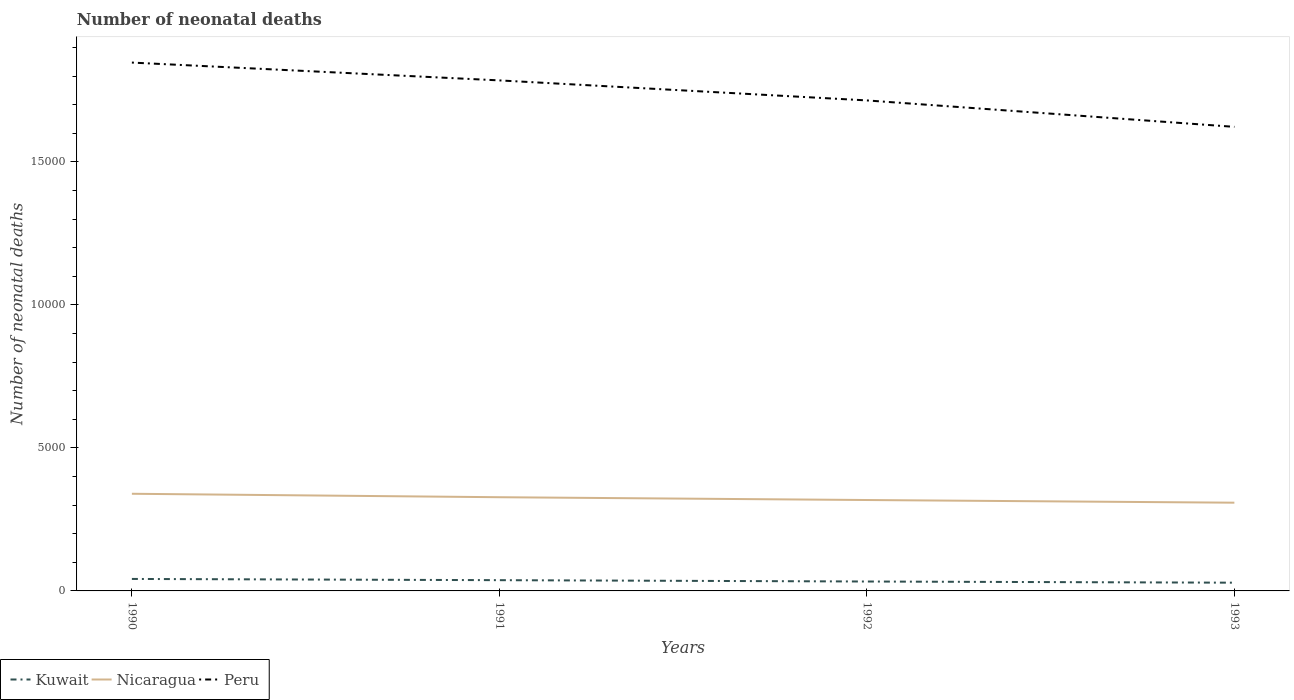Does the line corresponding to Peru intersect with the line corresponding to Nicaragua?
Your response must be concise. No. Across all years, what is the maximum number of neonatal deaths in in Kuwait?
Your answer should be very brief. 288. What is the total number of neonatal deaths in in Peru in the graph?
Provide a succinct answer. 1323. What is the difference between the highest and the second highest number of neonatal deaths in in Peru?
Offer a terse response. 2247. Is the number of neonatal deaths in in Kuwait strictly greater than the number of neonatal deaths in in Peru over the years?
Offer a very short reply. Yes. Are the values on the major ticks of Y-axis written in scientific E-notation?
Provide a short and direct response. No. Does the graph contain any zero values?
Your response must be concise. No. Where does the legend appear in the graph?
Provide a short and direct response. Bottom left. How many legend labels are there?
Keep it short and to the point. 3. How are the legend labels stacked?
Provide a succinct answer. Horizontal. What is the title of the graph?
Offer a very short reply. Number of neonatal deaths. Does "Indonesia" appear as one of the legend labels in the graph?
Provide a short and direct response. No. What is the label or title of the Y-axis?
Make the answer very short. Number of neonatal deaths. What is the Number of neonatal deaths of Kuwait in 1990?
Provide a short and direct response. 419. What is the Number of neonatal deaths of Nicaragua in 1990?
Provide a succinct answer. 3397. What is the Number of neonatal deaths of Peru in 1990?
Provide a succinct answer. 1.85e+04. What is the Number of neonatal deaths of Kuwait in 1991?
Make the answer very short. 376. What is the Number of neonatal deaths of Nicaragua in 1991?
Your answer should be compact. 3276. What is the Number of neonatal deaths of Peru in 1991?
Offer a terse response. 1.78e+04. What is the Number of neonatal deaths in Kuwait in 1992?
Your answer should be compact. 329. What is the Number of neonatal deaths of Nicaragua in 1992?
Provide a succinct answer. 3178. What is the Number of neonatal deaths of Peru in 1992?
Offer a very short reply. 1.71e+04. What is the Number of neonatal deaths in Kuwait in 1993?
Provide a short and direct response. 288. What is the Number of neonatal deaths in Nicaragua in 1993?
Keep it short and to the point. 3085. What is the Number of neonatal deaths of Peru in 1993?
Offer a terse response. 1.62e+04. Across all years, what is the maximum Number of neonatal deaths in Kuwait?
Make the answer very short. 419. Across all years, what is the maximum Number of neonatal deaths of Nicaragua?
Ensure brevity in your answer.  3397. Across all years, what is the maximum Number of neonatal deaths in Peru?
Your answer should be very brief. 1.85e+04. Across all years, what is the minimum Number of neonatal deaths of Kuwait?
Your answer should be compact. 288. Across all years, what is the minimum Number of neonatal deaths in Nicaragua?
Provide a short and direct response. 3085. Across all years, what is the minimum Number of neonatal deaths in Peru?
Keep it short and to the point. 1.62e+04. What is the total Number of neonatal deaths of Kuwait in the graph?
Offer a terse response. 1412. What is the total Number of neonatal deaths in Nicaragua in the graph?
Provide a succinct answer. 1.29e+04. What is the total Number of neonatal deaths of Peru in the graph?
Your answer should be very brief. 6.97e+04. What is the difference between the Number of neonatal deaths of Kuwait in 1990 and that in 1991?
Offer a very short reply. 43. What is the difference between the Number of neonatal deaths of Nicaragua in 1990 and that in 1991?
Your answer should be compact. 121. What is the difference between the Number of neonatal deaths in Peru in 1990 and that in 1991?
Provide a short and direct response. 623. What is the difference between the Number of neonatal deaths in Kuwait in 1990 and that in 1992?
Make the answer very short. 90. What is the difference between the Number of neonatal deaths in Nicaragua in 1990 and that in 1992?
Keep it short and to the point. 219. What is the difference between the Number of neonatal deaths in Peru in 1990 and that in 1992?
Offer a terse response. 1323. What is the difference between the Number of neonatal deaths in Kuwait in 1990 and that in 1993?
Offer a very short reply. 131. What is the difference between the Number of neonatal deaths of Nicaragua in 1990 and that in 1993?
Ensure brevity in your answer.  312. What is the difference between the Number of neonatal deaths in Peru in 1990 and that in 1993?
Ensure brevity in your answer.  2247. What is the difference between the Number of neonatal deaths in Kuwait in 1991 and that in 1992?
Give a very brief answer. 47. What is the difference between the Number of neonatal deaths of Peru in 1991 and that in 1992?
Your answer should be compact. 700. What is the difference between the Number of neonatal deaths in Kuwait in 1991 and that in 1993?
Your response must be concise. 88. What is the difference between the Number of neonatal deaths in Nicaragua in 1991 and that in 1993?
Give a very brief answer. 191. What is the difference between the Number of neonatal deaths of Peru in 1991 and that in 1993?
Provide a succinct answer. 1624. What is the difference between the Number of neonatal deaths of Nicaragua in 1992 and that in 1993?
Make the answer very short. 93. What is the difference between the Number of neonatal deaths in Peru in 1992 and that in 1993?
Your response must be concise. 924. What is the difference between the Number of neonatal deaths of Kuwait in 1990 and the Number of neonatal deaths of Nicaragua in 1991?
Provide a succinct answer. -2857. What is the difference between the Number of neonatal deaths of Kuwait in 1990 and the Number of neonatal deaths of Peru in 1991?
Your answer should be very brief. -1.74e+04. What is the difference between the Number of neonatal deaths in Nicaragua in 1990 and the Number of neonatal deaths in Peru in 1991?
Give a very brief answer. -1.45e+04. What is the difference between the Number of neonatal deaths in Kuwait in 1990 and the Number of neonatal deaths in Nicaragua in 1992?
Offer a very short reply. -2759. What is the difference between the Number of neonatal deaths of Kuwait in 1990 and the Number of neonatal deaths of Peru in 1992?
Your answer should be compact. -1.67e+04. What is the difference between the Number of neonatal deaths of Nicaragua in 1990 and the Number of neonatal deaths of Peru in 1992?
Provide a short and direct response. -1.38e+04. What is the difference between the Number of neonatal deaths in Kuwait in 1990 and the Number of neonatal deaths in Nicaragua in 1993?
Your answer should be compact. -2666. What is the difference between the Number of neonatal deaths of Kuwait in 1990 and the Number of neonatal deaths of Peru in 1993?
Your response must be concise. -1.58e+04. What is the difference between the Number of neonatal deaths in Nicaragua in 1990 and the Number of neonatal deaths in Peru in 1993?
Your answer should be very brief. -1.28e+04. What is the difference between the Number of neonatal deaths in Kuwait in 1991 and the Number of neonatal deaths in Nicaragua in 1992?
Provide a short and direct response. -2802. What is the difference between the Number of neonatal deaths of Kuwait in 1991 and the Number of neonatal deaths of Peru in 1992?
Give a very brief answer. -1.68e+04. What is the difference between the Number of neonatal deaths in Nicaragua in 1991 and the Number of neonatal deaths in Peru in 1992?
Keep it short and to the point. -1.39e+04. What is the difference between the Number of neonatal deaths of Kuwait in 1991 and the Number of neonatal deaths of Nicaragua in 1993?
Keep it short and to the point. -2709. What is the difference between the Number of neonatal deaths of Kuwait in 1991 and the Number of neonatal deaths of Peru in 1993?
Offer a very short reply. -1.58e+04. What is the difference between the Number of neonatal deaths in Nicaragua in 1991 and the Number of neonatal deaths in Peru in 1993?
Your response must be concise. -1.29e+04. What is the difference between the Number of neonatal deaths of Kuwait in 1992 and the Number of neonatal deaths of Nicaragua in 1993?
Give a very brief answer. -2756. What is the difference between the Number of neonatal deaths in Kuwait in 1992 and the Number of neonatal deaths in Peru in 1993?
Make the answer very short. -1.59e+04. What is the difference between the Number of neonatal deaths of Nicaragua in 1992 and the Number of neonatal deaths of Peru in 1993?
Your answer should be very brief. -1.30e+04. What is the average Number of neonatal deaths in Kuwait per year?
Provide a short and direct response. 353. What is the average Number of neonatal deaths of Nicaragua per year?
Keep it short and to the point. 3234. What is the average Number of neonatal deaths in Peru per year?
Your answer should be very brief. 1.74e+04. In the year 1990, what is the difference between the Number of neonatal deaths in Kuwait and Number of neonatal deaths in Nicaragua?
Your response must be concise. -2978. In the year 1990, what is the difference between the Number of neonatal deaths of Kuwait and Number of neonatal deaths of Peru?
Offer a very short reply. -1.81e+04. In the year 1990, what is the difference between the Number of neonatal deaths of Nicaragua and Number of neonatal deaths of Peru?
Give a very brief answer. -1.51e+04. In the year 1991, what is the difference between the Number of neonatal deaths in Kuwait and Number of neonatal deaths in Nicaragua?
Ensure brevity in your answer.  -2900. In the year 1991, what is the difference between the Number of neonatal deaths of Kuwait and Number of neonatal deaths of Peru?
Give a very brief answer. -1.75e+04. In the year 1991, what is the difference between the Number of neonatal deaths in Nicaragua and Number of neonatal deaths in Peru?
Your response must be concise. -1.46e+04. In the year 1992, what is the difference between the Number of neonatal deaths of Kuwait and Number of neonatal deaths of Nicaragua?
Provide a short and direct response. -2849. In the year 1992, what is the difference between the Number of neonatal deaths of Kuwait and Number of neonatal deaths of Peru?
Your response must be concise. -1.68e+04. In the year 1992, what is the difference between the Number of neonatal deaths in Nicaragua and Number of neonatal deaths in Peru?
Give a very brief answer. -1.40e+04. In the year 1993, what is the difference between the Number of neonatal deaths of Kuwait and Number of neonatal deaths of Nicaragua?
Your answer should be very brief. -2797. In the year 1993, what is the difference between the Number of neonatal deaths in Kuwait and Number of neonatal deaths in Peru?
Provide a succinct answer. -1.59e+04. In the year 1993, what is the difference between the Number of neonatal deaths of Nicaragua and Number of neonatal deaths of Peru?
Keep it short and to the point. -1.31e+04. What is the ratio of the Number of neonatal deaths of Kuwait in 1990 to that in 1991?
Give a very brief answer. 1.11. What is the ratio of the Number of neonatal deaths in Nicaragua in 1990 to that in 1991?
Make the answer very short. 1.04. What is the ratio of the Number of neonatal deaths of Peru in 1990 to that in 1991?
Your response must be concise. 1.03. What is the ratio of the Number of neonatal deaths of Kuwait in 1990 to that in 1992?
Ensure brevity in your answer.  1.27. What is the ratio of the Number of neonatal deaths in Nicaragua in 1990 to that in 1992?
Make the answer very short. 1.07. What is the ratio of the Number of neonatal deaths of Peru in 1990 to that in 1992?
Ensure brevity in your answer.  1.08. What is the ratio of the Number of neonatal deaths of Kuwait in 1990 to that in 1993?
Your response must be concise. 1.45. What is the ratio of the Number of neonatal deaths in Nicaragua in 1990 to that in 1993?
Provide a short and direct response. 1.1. What is the ratio of the Number of neonatal deaths in Peru in 1990 to that in 1993?
Your answer should be compact. 1.14. What is the ratio of the Number of neonatal deaths of Kuwait in 1991 to that in 1992?
Give a very brief answer. 1.14. What is the ratio of the Number of neonatal deaths in Nicaragua in 1991 to that in 1992?
Keep it short and to the point. 1.03. What is the ratio of the Number of neonatal deaths of Peru in 1991 to that in 1992?
Your response must be concise. 1.04. What is the ratio of the Number of neonatal deaths of Kuwait in 1991 to that in 1993?
Offer a terse response. 1.31. What is the ratio of the Number of neonatal deaths of Nicaragua in 1991 to that in 1993?
Your answer should be very brief. 1.06. What is the ratio of the Number of neonatal deaths of Peru in 1991 to that in 1993?
Offer a very short reply. 1.1. What is the ratio of the Number of neonatal deaths of Kuwait in 1992 to that in 1993?
Provide a short and direct response. 1.14. What is the ratio of the Number of neonatal deaths of Nicaragua in 1992 to that in 1993?
Ensure brevity in your answer.  1.03. What is the ratio of the Number of neonatal deaths of Peru in 1992 to that in 1993?
Ensure brevity in your answer.  1.06. What is the difference between the highest and the second highest Number of neonatal deaths of Nicaragua?
Your answer should be compact. 121. What is the difference between the highest and the second highest Number of neonatal deaths in Peru?
Give a very brief answer. 623. What is the difference between the highest and the lowest Number of neonatal deaths in Kuwait?
Ensure brevity in your answer.  131. What is the difference between the highest and the lowest Number of neonatal deaths of Nicaragua?
Your answer should be very brief. 312. What is the difference between the highest and the lowest Number of neonatal deaths in Peru?
Your answer should be very brief. 2247. 